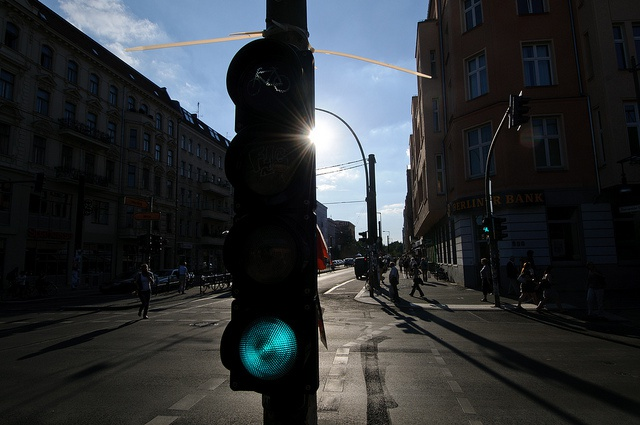Describe the objects in this image and their specific colors. I can see traffic light in black, gray, darkgray, and white tones, traffic light in black, teal, and gray tones, people in black and gray tones, people in black, gray, darkgreen, and maroon tones, and traffic light in black, gray, and darkgray tones in this image. 